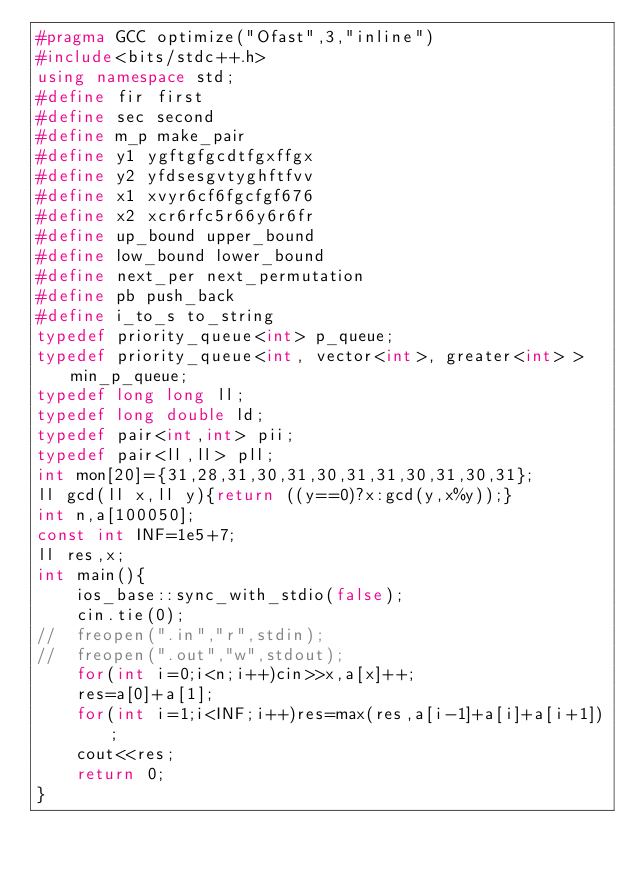Convert code to text. <code><loc_0><loc_0><loc_500><loc_500><_C++_>#pragma GCC optimize("Ofast",3,"inline")
#include<bits/stdc++.h>
using namespace std;
#define fir first
#define sec second
#define m_p make_pair
#define y1 ygftgfgcdtfgxffgx
#define y2 yfdsesgvtyghftfvv
#define x1 xvyr6cf6fgcfgf676
#define x2 xcr6rfc5r66y6r6fr
#define up_bound upper_bound
#define low_bound lower_bound
#define next_per next_permutation
#define pb push_back
#define i_to_s to_string
typedef priority_queue<int> p_queue;
typedef priority_queue<int, vector<int>, greater<int> > min_p_queue;
typedef long long ll;
typedef long double ld;
typedef pair<int,int> pii;
typedef pair<ll,ll> pll;
int mon[20]={31,28,31,30,31,30,31,31,30,31,30,31};
ll gcd(ll x,ll y){return ((y==0)?x:gcd(y,x%y));}
int n,a[100050];
const int INF=1e5+7;
ll res,x;
int main(){
	ios_base::sync_with_stdio(false);
	cin.tie(0);
//	freopen(".in","r",stdin);
//	freopen(".out","w",stdout);
	for(int i=0;i<n;i++)cin>>x,a[x]++;
	res=a[0]+a[1];
	for(int i=1;i<INF;i++)res=max(res,a[i-1]+a[i]+a[i+1]);
	cout<<res;
	return 0;
}
</code> 